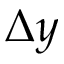<formula> <loc_0><loc_0><loc_500><loc_500>\Delta y</formula> 